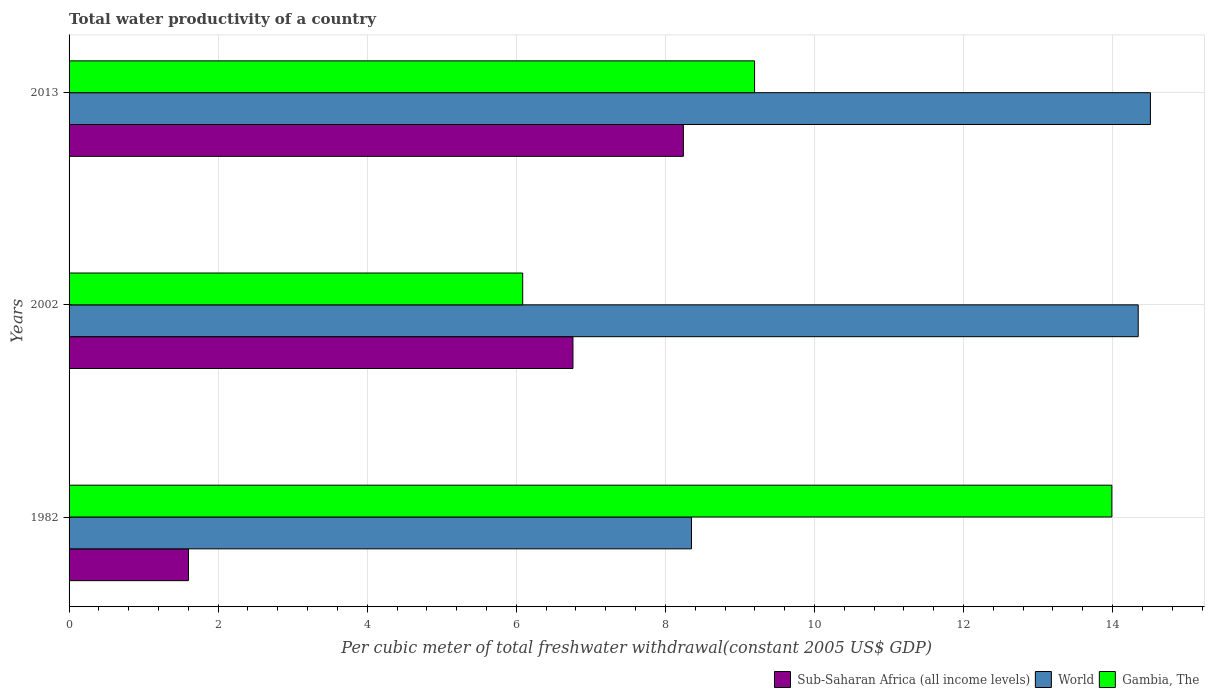How many different coloured bars are there?
Ensure brevity in your answer.  3. Are the number of bars per tick equal to the number of legend labels?
Provide a short and direct response. Yes. In how many cases, is the number of bars for a given year not equal to the number of legend labels?
Keep it short and to the point. 0. What is the total water productivity in Gambia, The in 1982?
Your answer should be very brief. 13.99. Across all years, what is the maximum total water productivity in Sub-Saharan Africa (all income levels)?
Provide a short and direct response. 8.24. Across all years, what is the minimum total water productivity in Sub-Saharan Africa (all income levels)?
Keep it short and to the point. 1.6. What is the total total water productivity in Gambia, The in the graph?
Your response must be concise. 29.27. What is the difference between the total water productivity in Sub-Saharan Africa (all income levels) in 2002 and that in 2013?
Your answer should be compact. -1.48. What is the difference between the total water productivity in Gambia, The in 1982 and the total water productivity in World in 2002?
Offer a very short reply. -0.35. What is the average total water productivity in Sub-Saharan Africa (all income levels) per year?
Offer a terse response. 5.53. In the year 2002, what is the difference between the total water productivity in World and total water productivity in Sub-Saharan Africa (all income levels)?
Give a very brief answer. 7.58. What is the ratio of the total water productivity in World in 1982 to that in 2002?
Keep it short and to the point. 0.58. Is the total water productivity in Gambia, The in 2002 less than that in 2013?
Your answer should be very brief. Yes. Is the difference between the total water productivity in World in 1982 and 2013 greater than the difference between the total water productivity in Sub-Saharan Africa (all income levels) in 1982 and 2013?
Offer a very short reply. Yes. What is the difference between the highest and the second highest total water productivity in Gambia, The?
Provide a succinct answer. 4.79. What is the difference between the highest and the lowest total water productivity in Gambia, The?
Your answer should be compact. 7.9. In how many years, is the total water productivity in Gambia, The greater than the average total water productivity in Gambia, The taken over all years?
Provide a succinct answer. 1. What does the 1st bar from the top in 1982 represents?
Keep it short and to the point. Gambia, The. What does the 2nd bar from the bottom in 2002 represents?
Offer a terse response. World. Is it the case that in every year, the sum of the total water productivity in Gambia, The and total water productivity in Sub-Saharan Africa (all income levels) is greater than the total water productivity in World?
Provide a short and direct response. No. Are all the bars in the graph horizontal?
Make the answer very short. Yes. Does the graph contain any zero values?
Provide a succinct answer. No. How many legend labels are there?
Ensure brevity in your answer.  3. What is the title of the graph?
Your answer should be very brief. Total water productivity of a country. What is the label or title of the X-axis?
Offer a terse response. Per cubic meter of total freshwater withdrawal(constant 2005 US$ GDP). What is the label or title of the Y-axis?
Your answer should be very brief. Years. What is the Per cubic meter of total freshwater withdrawal(constant 2005 US$ GDP) of Sub-Saharan Africa (all income levels) in 1982?
Your answer should be very brief. 1.6. What is the Per cubic meter of total freshwater withdrawal(constant 2005 US$ GDP) of World in 1982?
Offer a terse response. 8.35. What is the Per cubic meter of total freshwater withdrawal(constant 2005 US$ GDP) in Gambia, The in 1982?
Offer a very short reply. 13.99. What is the Per cubic meter of total freshwater withdrawal(constant 2005 US$ GDP) of Sub-Saharan Africa (all income levels) in 2002?
Provide a succinct answer. 6.76. What is the Per cubic meter of total freshwater withdrawal(constant 2005 US$ GDP) of World in 2002?
Ensure brevity in your answer.  14.34. What is the Per cubic meter of total freshwater withdrawal(constant 2005 US$ GDP) of Gambia, The in 2002?
Keep it short and to the point. 6.09. What is the Per cubic meter of total freshwater withdrawal(constant 2005 US$ GDP) in Sub-Saharan Africa (all income levels) in 2013?
Offer a terse response. 8.24. What is the Per cubic meter of total freshwater withdrawal(constant 2005 US$ GDP) in World in 2013?
Provide a short and direct response. 14.51. What is the Per cubic meter of total freshwater withdrawal(constant 2005 US$ GDP) in Gambia, The in 2013?
Provide a succinct answer. 9.2. Across all years, what is the maximum Per cubic meter of total freshwater withdrawal(constant 2005 US$ GDP) in Sub-Saharan Africa (all income levels)?
Offer a very short reply. 8.24. Across all years, what is the maximum Per cubic meter of total freshwater withdrawal(constant 2005 US$ GDP) in World?
Provide a succinct answer. 14.51. Across all years, what is the maximum Per cubic meter of total freshwater withdrawal(constant 2005 US$ GDP) in Gambia, The?
Offer a terse response. 13.99. Across all years, what is the minimum Per cubic meter of total freshwater withdrawal(constant 2005 US$ GDP) in Sub-Saharan Africa (all income levels)?
Give a very brief answer. 1.6. Across all years, what is the minimum Per cubic meter of total freshwater withdrawal(constant 2005 US$ GDP) in World?
Provide a short and direct response. 8.35. Across all years, what is the minimum Per cubic meter of total freshwater withdrawal(constant 2005 US$ GDP) in Gambia, The?
Give a very brief answer. 6.09. What is the total Per cubic meter of total freshwater withdrawal(constant 2005 US$ GDP) of Sub-Saharan Africa (all income levels) in the graph?
Offer a very short reply. 16.6. What is the total Per cubic meter of total freshwater withdrawal(constant 2005 US$ GDP) of World in the graph?
Give a very brief answer. 37.2. What is the total Per cubic meter of total freshwater withdrawal(constant 2005 US$ GDP) of Gambia, The in the graph?
Make the answer very short. 29.27. What is the difference between the Per cubic meter of total freshwater withdrawal(constant 2005 US$ GDP) in Sub-Saharan Africa (all income levels) in 1982 and that in 2002?
Your answer should be very brief. -5.16. What is the difference between the Per cubic meter of total freshwater withdrawal(constant 2005 US$ GDP) in World in 1982 and that in 2002?
Offer a very short reply. -5.99. What is the difference between the Per cubic meter of total freshwater withdrawal(constant 2005 US$ GDP) of Gambia, The in 1982 and that in 2002?
Provide a succinct answer. 7.9. What is the difference between the Per cubic meter of total freshwater withdrawal(constant 2005 US$ GDP) of Sub-Saharan Africa (all income levels) in 1982 and that in 2013?
Offer a terse response. -6.64. What is the difference between the Per cubic meter of total freshwater withdrawal(constant 2005 US$ GDP) of World in 1982 and that in 2013?
Ensure brevity in your answer.  -6.16. What is the difference between the Per cubic meter of total freshwater withdrawal(constant 2005 US$ GDP) in Gambia, The in 1982 and that in 2013?
Keep it short and to the point. 4.79. What is the difference between the Per cubic meter of total freshwater withdrawal(constant 2005 US$ GDP) of Sub-Saharan Africa (all income levels) in 2002 and that in 2013?
Offer a terse response. -1.48. What is the difference between the Per cubic meter of total freshwater withdrawal(constant 2005 US$ GDP) in World in 2002 and that in 2013?
Your answer should be very brief. -0.16. What is the difference between the Per cubic meter of total freshwater withdrawal(constant 2005 US$ GDP) in Gambia, The in 2002 and that in 2013?
Keep it short and to the point. -3.11. What is the difference between the Per cubic meter of total freshwater withdrawal(constant 2005 US$ GDP) in Sub-Saharan Africa (all income levels) in 1982 and the Per cubic meter of total freshwater withdrawal(constant 2005 US$ GDP) in World in 2002?
Your answer should be very brief. -12.74. What is the difference between the Per cubic meter of total freshwater withdrawal(constant 2005 US$ GDP) of Sub-Saharan Africa (all income levels) in 1982 and the Per cubic meter of total freshwater withdrawal(constant 2005 US$ GDP) of Gambia, The in 2002?
Give a very brief answer. -4.48. What is the difference between the Per cubic meter of total freshwater withdrawal(constant 2005 US$ GDP) of World in 1982 and the Per cubic meter of total freshwater withdrawal(constant 2005 US$ GDP) of Gambia, The in 2002?
Make the answer very short. 2.26. What is the difference between the Per cubic meter of total freshwater withdrawal(constant 2005 US$ GDP) in Sub-Saharan Africa (all income levels) in 1982 and the Per cubic meter of total freshwater withdrawal(constant 2005 US$ GDP) in World in 2013?
Your answer should be very brief. -12.9. What is the difference between the Per cubic meter of total freshwater withdrawal(constant 2005 US$ GDP) in Sub-Saharan Africa (all income levels) in 1982 and the Per cubic meter of total freshwater withdrawal(constant 2005 US$ GDP) in Gambia, The in 2013?
Provide a succinct answer. -7.59. What is the difference between the Per cubic meter of total freshwater withdrawal(constant 2005 US$ GDP) in World in 1982 and the Per cubic meter of total freshwater withdrawal(constant 2005 US$ GDP) in Gambia, The in 2013?
Your answer should be compact. -0.85. What is the difference between the Per cubic meter of total freshwater withdrawal(constant 2005 US$ GDP) of Sub-Saharan Africa (all income levels) in 2002 and the Per cubic meter of total freshwater withdrawal(constant 2005 US$ GDP) of World in 2013?
Keep it short and to the point. -7.75. What is the difference between the Per cubic meter of total freshwater withdrawal(constant 2005 US$ GDP) in Sub-Saharan Africa (all income levels) in 2002 and the Per cubic meter of total freshwater withdrawal(constant 2005 US$ GDP) in Gambia, The in 2013?
Keep it short and to the point. -2.44. What is the difference between the Per cubic meter of total freshwater withdrawal(constant 2005 US$ GDP) in World in 2002 and the Per cubic meter of total freshwater withdrawal(constant 2005 US$ GDP) in Gambia, The in 2013?
Ensure brevity in your answer.  5.15. What is the average Per cubic meter of total freshwater withdrawal(constant 2005 US$ GDP) in Sub-Saharan Africa (all income levels) per year?
Make the answer very short. 5.53. What is the average Per cubic meter of total freshwater withdrawal(constant 2005 US$ GDP) of World per year?
Provide a short and direct response. 12.4. What is the average Per cubic meter of total freshwater withdrawal(constant 2005 US$ GDP) in Gambia, The per year?
Offer a terse response. 9.76. In the year 1982, what is the difference between the Per cubic meter of total freshwater withdrawal(constant 2005 US$ GDP) in Sub-Saharan Africa (all income levels) and Per cubic meter of total freshwater withdrawal(constant 2005 US$ GDP) in World?
Give a very brief answer. -6.75. In the year 1982, what is the difference between the Per cubic meter of total freshwater withdrawal(constant 2005 US$ GDP) in Sub-Saharan Africa (all income levels) and Per cubic meter of total freshwater withdrawal(constant 2005 US$ GDP) in Gambia, The?
Give a very brief answer. -12.39. In the year 1982, what is the difference between the Per cubic meter of total freshwater withdrawal(constant 2005 US$ GDP) of World and Per cubic meter of total freshwater withdrawal(constant 2005 US$ GDP) of Gambia, The?
Keep it short and to the point. -5.64. In the year 2002, what is the difference between the Per cubic meter of total freshwater withdrawal(constant 2005 US$ GDP) of Sub-Saharan Africa (all income levels) and Per cubic meter of total freshwater withdrawal(constant 2005 US$ GDP) of World?
Provide a short and direct response. -7.58. In the year 2002, what is the difference between the Per cubic meter of total freshwater withdrawal(constant 2005 US$ GDP) of Sub-Saharan Africa (all income levels) and Per cubic meter of total freshwater withdrawal(constant 2005 US$ GDP) of Gambia, The?
Make the answer very short. 0.67. In the year 2002, what is the difference between the Per cubic meter of total freshwater withdrawal(constant 2005 US$ GDP) in World and Per cubic meter of total freshwater withdrawal(constant 2005 US$ GDP) in Gambia, The?
Make the answer very short. 8.26. In the year 2013, what is the difference between the Per cubic meter of total freshwater withdrawal(constant 2005 US$ GDP) of Sub-Saharan Africa (all income levels) and Per cubic meter of total freshwater withdrawal(constant 2005 US$ GDP) of World?
Provide a short and direct response. -6.27. In the year 2013, what is the difference between the Per cubic meter of total freshwater withdrawal(constant 2005 US$ GDP) of Sub-Saharan Africa (all income levels) and Per cubic meter of total freshwater withdrawal(constant 2005 US$ GDP) of Gambia, The?
Keep it short and to the point. -0.95. In the year 2013, what is the difference between the Per cubic meter of total freshwater withdrawal(constant 2005 US$ GDP) of World and Per cubic meter of total freshwater withdrawal(constant 2005 US$ GDP) of Gambia, The?
Your answer should be very brief. 5.31. What is the ratio of the Per cubic meter of total freshwater withdrawal(constant 2005 US$ GDP) of Sub-Saharan Africa (all income levels) in 1982 to that in 2002?
Your response must be concise. 0.24. What is the ratio of the Per cubic meter of total freshwater withdrawal(constant 2005 US$ GDP) in World in 1982 to that in 2002?
Offer a terse response. 0.58. What is the ratio of the Per cubic meter of total freshwater withdrawal(constant 2005 US$ GDP) in Gambia, The in 1982 to that in 2002?
Keep it short and to the point. 2.3. What is the ratio of the Per cubic meter of total freshwater withdrawal(constant 2005 US$ GDP) in Sub-Saharan Africa (all income levels) in 1982 to that in 2013?
Provide a short and direct response. 0.19. What is the ratio of the Per cubic meter of total freshwater withdrawal(constant 2005 US$ GDP) of World in 1982 to that in 2013?
Keep it short and to the point. 0.58. What is the ratio of the Per cubic meter of total freshwater withdrawal(constant 2005 US$ GDP) in Gambia, The in 1982 to that in 2013?
Give a very brief answer. 1.52. What is the ratio of the Per cubic meter of total freshwater withdrawal(constant 2005 US$ GDP) of Sub-Saharan Africa (all income levels) in 2002 to that in 2013?
Keep it short and to the point. 0.82. What is the ratio of the Per cubic meter of total freshwater withdrawal(constant 2005 US$ GDP) in World in 2002 to that in 2013?
Your answer should be compact. 0.99. What is the ratio of the Per cubic meter of total freshwater withdrawal(constant 2005 US$ GDP) in Gambia, The in 2002 to that in 2013?
Offer a very short reply. 0.66. What is the difference between the highest and the second highest Per cubic meter of total freshwater withdrawal(constant 2005 US$ GDP) of Sub-Saharan Africa (all income levels)?
Offer a very short reply. 1.48. What is the difference between the highest and the second highest Per cubic meter of total freshwater withdrawal(constant 2005 US$ GDP) in World?
Offer a very short reply. 0.16. What is the difference between the highest and the second highest Per cubic meter of total freshwater withdrawal(constant 2005 US$ GDP) of Gambia, The?
Keep it short and to the point. 4.79. What is the difference between the highest and the lowest Per cubic meter of total freshwater withdrawal(constant 2005 US$ GDP) of Sub-Saharan Africa (all income levels)?
Provide a short and direct response. 6.64. What is the difference between the highest and the lowest Per cubic meter of total freshwater withdrawal(constant 2005 US$ GDP) of World?
Your answer should be compact. 6.16. What is the difference between the highest and the lowest Per cubic meter of total freshwater withdrawal(constant 2005 US$ GDP) in Gambia, The?
Your answer should be very brief. 7.9. 